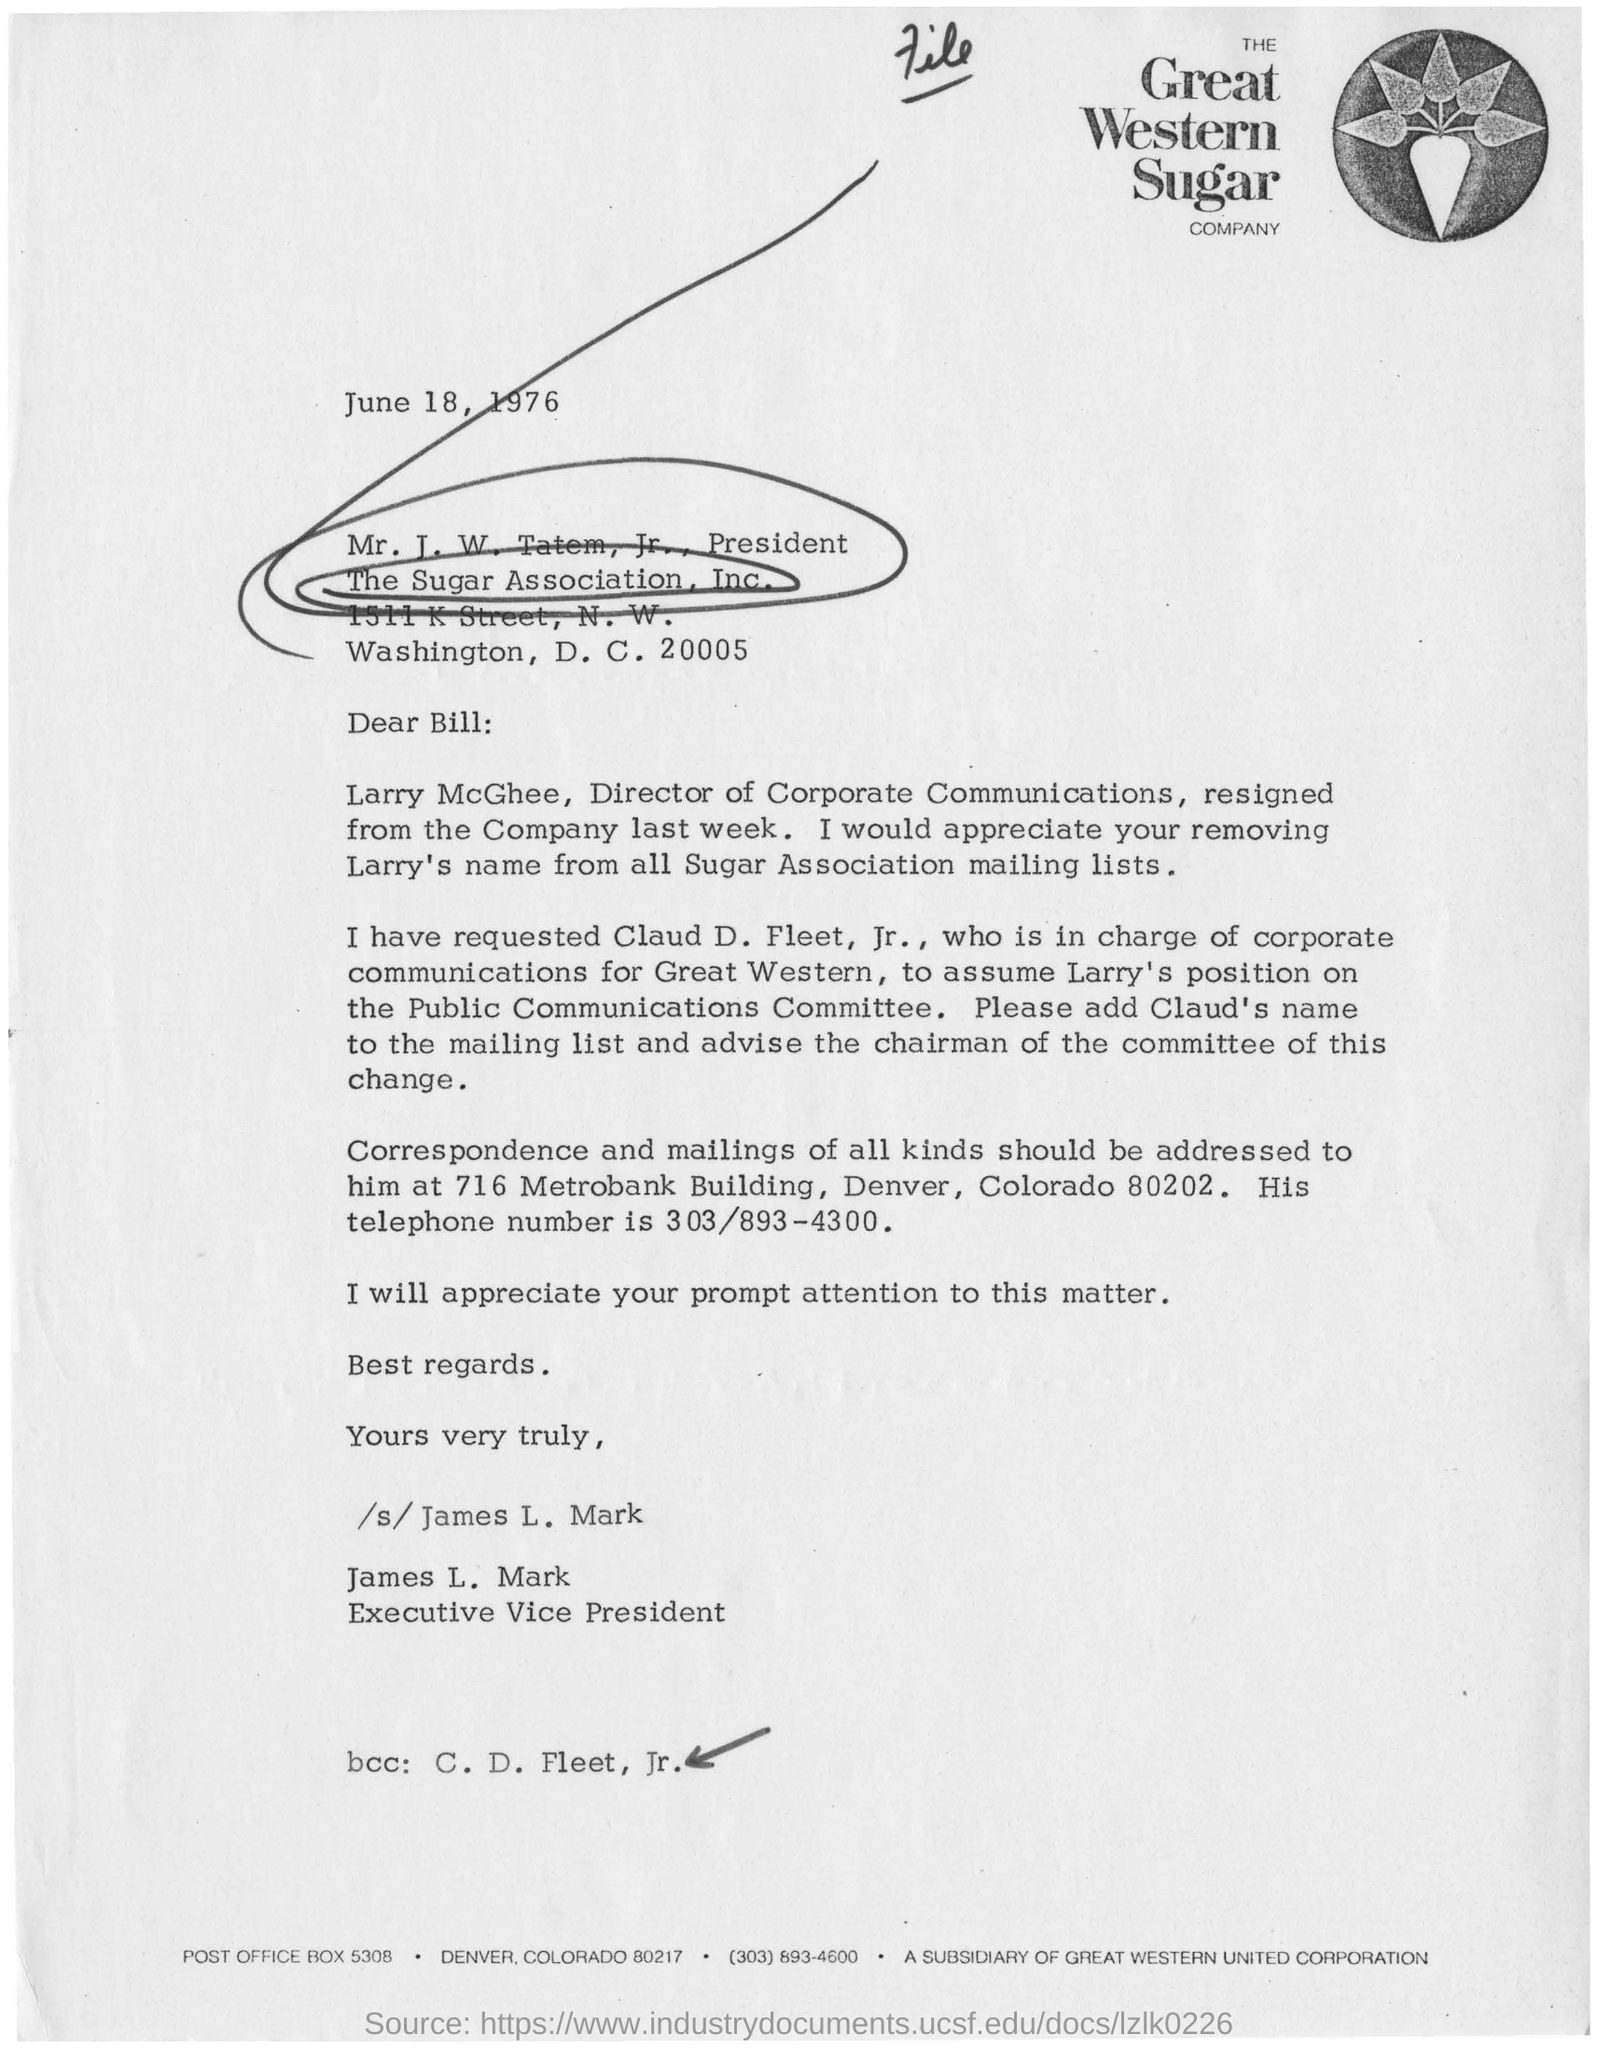Give some essential details in this illustration. The Great Western Sugar Company is mentioned in the letterhead. Larry McGhee is the director of Corporate Communication. James L. Mark is the Executive Vice President. The date mentioned in the letter is June 18, 1976. 